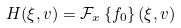<formula> <loc_0><loc_0><loc_500><loc_500>H ( \xi , v ) = \mathcal { F } _ { x } \left \{ f _ { 0 } \right \} ( \xi , v )</formula> 